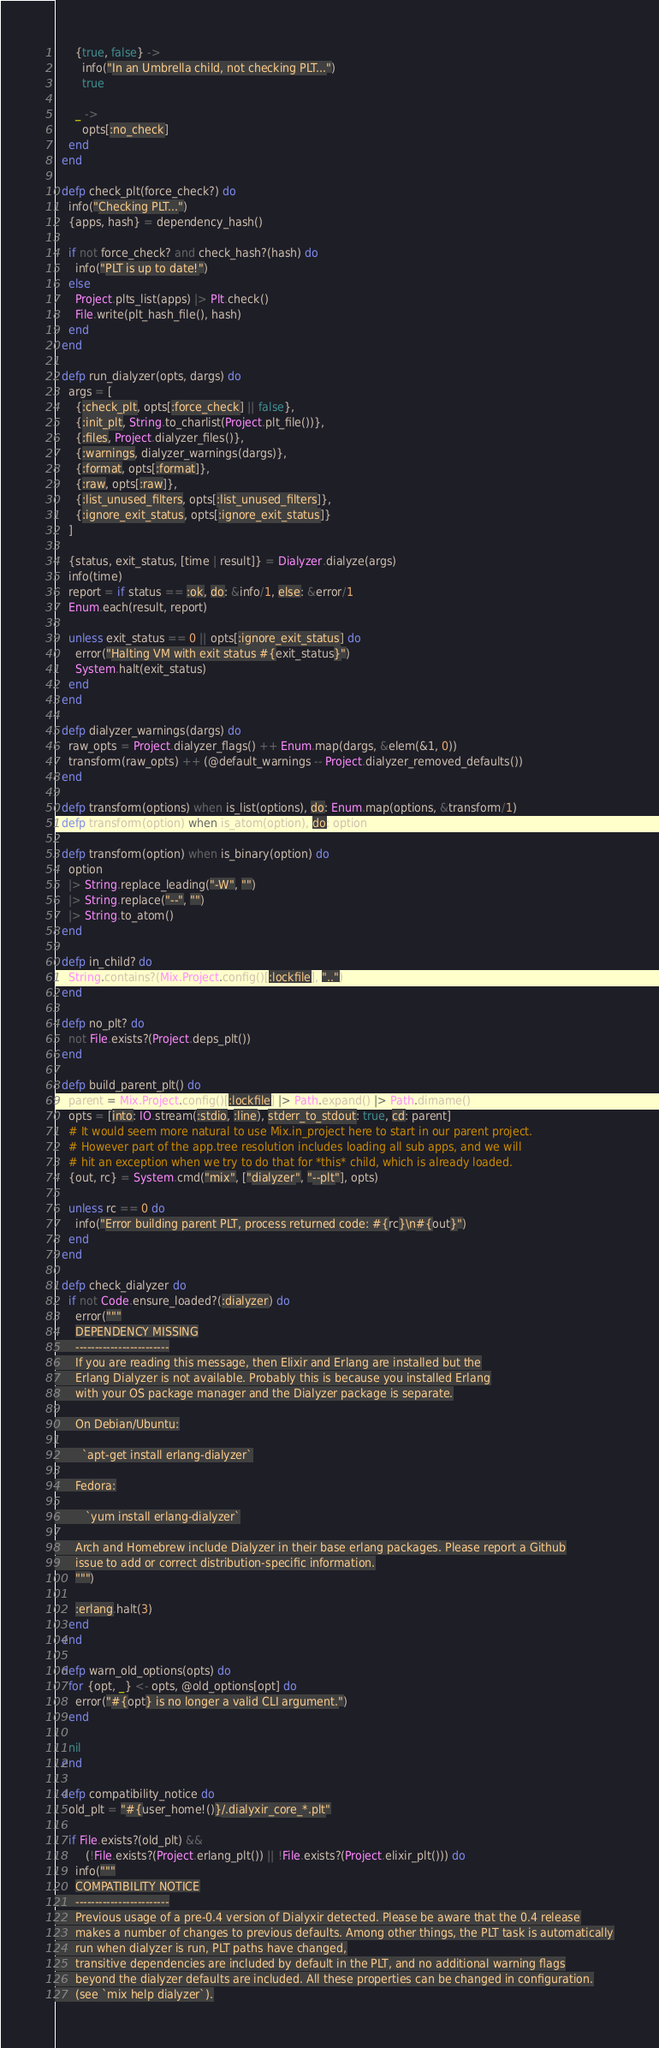Convert code to text. <code><loc_0><loc_0><loc_500><loc_500><_Elixir_>      {true, false} ->
        info("In an Umbrella child, not checking PLT...")
        true

      _ ->
        opts[:no_check]
    end
  end

  defp check_plt(force_check?) do
    info("Checking PLT...")
    {apps, hash} = dependency_hash()

    if not force_check? and check_hash?(hash) do
      info("PLT is up to date!")
    else
      Project.plts_list(apps) |> Plt.check()
      File.write(plt_hash_file(), hash)
    end
  end

  defp run_dialyzer(opts, dargs) do
    args = [
      {:check_plt, opts[:force_check] || false},
      {:init_plt, String.to_charlist(Project.plt_file())},
      {:files, Project.dialyzer_files()},
      {:warnings, dialyzer_warnings(dargs)},
      {:format, opts[:format]},
      {:raw, opts[:raw]},
      {:list_unused_filters, opts[:list_unused_filters]},
      {:ignore_exit_status, opts[:ignore_exit_status]}
    ]

    {status, exit_status, [time | result]} = Dialyzer.dialyze(args)
    info(time)
    report = if status == :ok, do: &info/1, else: &error/1
    Enum.each(result, report)

    unless exit_status == 0 || opts[:ignore_exit_status] do
      error("Halting VM with exit status #{exit_status}")
      System.halt(exit_status)
    end
  end

  defp dialyzer_warnings(dargs) do
    raw_opts = Project.dialyzer_flags() ++ Enum.map(dargs, &elem(&1, 0))
    transform(raw_opts) ++ (@default_warnings -- Project.dialyzer_removed_defaults())
  end

  defp transform(options) when is_list(options), do: Enum.map(options, &transform/1)
  defp transform(option) when is_atom(option), do: option

  defp transform(option) when is_binary(option) do
    option
    |> String.replace_leading("-W", "")
    |> String.replace("--", "")
    |> String.to_atom()
  end

  defp in_child? do
    String.contains?(Mix.Project.config()[:lockfile], "..")
  end

  defp no_plt? do
    not File.exists?(Project.deps_plt())
  end

  defp build_parent_plt() do
    parent = Mix.Project.config()[:lockfile] |> Path.expand() |> Path.dirname()
    opts = [into: IO.stream(:stdio, :line), stderr_to_stdout: true, cd: parent]
    # It would seem more natural to use Mix.in_project here to start in our parent project.
    # However part of the app.tree resolution includes loading all sub apps, and we will
    # hit an exception when we try to do that for *this* child, which is already loaded.
    {out, rc} = System.cmd("mix", ["dialyzer", "--plt"], opts)

    unless rc == 0 do
      info("Error building parent PLT, process returned code: #{rc}\n#{out}")
    end
  end

  defp check_dialyzer do
    if not Code.ensure_loaded?(:dialyzer) do
      error("""
      DEPENDENCY MISSING
      ------------------------
      If you are reading this message, then Elixir and Erlang are installed but the
      Erlang Dialyzer is not available. Probably this is because you installed Erlang
      with your OS package manager and the Dialyzer package is separate.

      On Debian/Ubuntu:

        `apt-get install erlang-dialyzer`

      Fedora:

         `yum install erlang-dialyzer`

      Arch and Homebrew include Dialyzer in their base erlang packages. Please report a Github
      issue to add or correct distribution-specific information.
      """)

      :erlang.halt(3)
    end
  end

  defp warn_old_options(opts) do
    for {opt, _} <- opts, @old_options[opt] do
      error("#{opt} is no longer a valid CLI argument.")
    end

    nil
  end

  defp compatibility_notice do
    old_plt = "#{user_home!()}/.dialyxir_core_*.plt"

    if File.exists?(old_plt) &&
         (!File.exists?(Project.erlang_plt()) || !File.exists?(Project.elixir_plt())) do
      info("""
      COMPATIBILITY NOTICE
      ------------------------
      Previous usage of a pre-0.4 version of Dialyxir detected. Please be aware that the 0.4 release
      makes a number of changes to previous defaults. Among other things, the PLT task is automatically
      run when dialyzer is run, PLT paths have changed,
      transitive dependencies are included by default in the PLT, and no additional warning flags
      beyond the dialyzer defaults are included. All these properties can be changed in configuration.
      (see `mix help dialyzer`).
</code> 